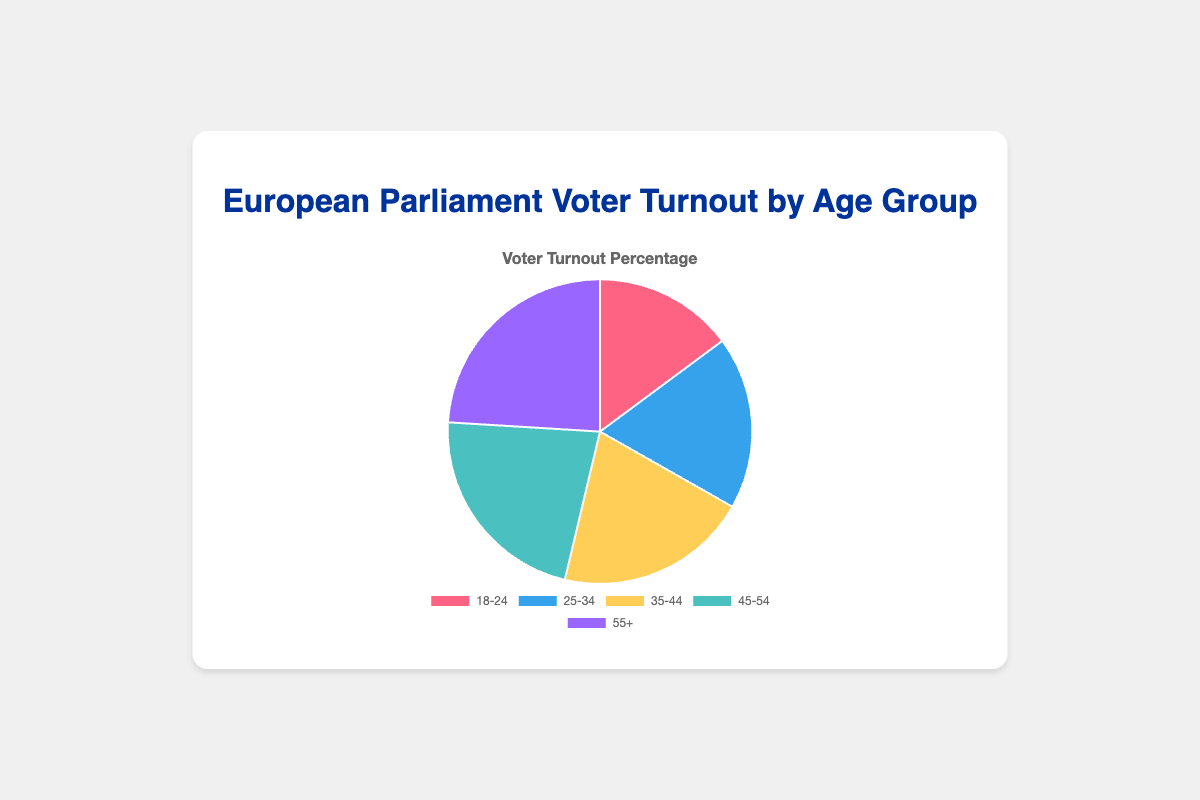What age group has the lowest voter turnout? We look at the pie chart and observe the data for each age group. The age group 18-24 has the lowest voter turnout percentage of 42%.
Answer: 18-24 Which age group has the highest voter turnout? By observing the pie chart, we identify that the age group 55+ has the highest voter turnout percentage of 68%.
Answer: 55+ What is the difference in voter turnout percentage between the 25-34 and 35-44 age groups? From the pie chart, the voter turnout for 25-34 is 52% and for 35-44 is 58%. The difference is 58% - 52% = 6%.
Answer: 6% How does the voter turnout for the 35-44 age group compare to the 45-54 age group? By comparing the pie chart sections, the 35-44 age group has a voter turnout of 58% while the 45-54 age group has 63%. Therefore, the 45-54 age group has a higher voter turnout.
Answer: 45-54 age group has a higher turnout What is the sum of the voter turnout percentages for the 18-24 and 55+ age groups? Adding the turnout percentages for these age groups from the pie chart, we get 42% + 68% = 110%.
Answer: 110% After analyzing all the age groups, what is the average voter turnout percentage? First, sum up the turnout percentages for all age groups: 42% + 52% + 58% + 63% + 68% = 283%. To find the average, divide by the number of age groups: 283% / 5 = 56.6%.
Answer: 56.6% What is the relationship between voter turnout in the 18-24 age group versus the 45-54 age group? The pie chart shows that the 18-24 age group has a 42% turnout while the 45-54 age group has 63%. Therefore, the 45-54 age group has a higher voter turnout.
Answer: 45-54 age group has a higher turnout What percentage of the total voter turnout is represented by the 35-44 age group? The total percentages sum up to 283%. The percentage portion represented by the 35-44 age group is (58 / 283) * 100 ≈ 20.49%.
Answer: 20.49% Which segment of the pie chart is represented in blue? Upon reviewing the color scheme in the pie chart, the blue segment correlates with the 25-34 age group.
Answer: 25-34 